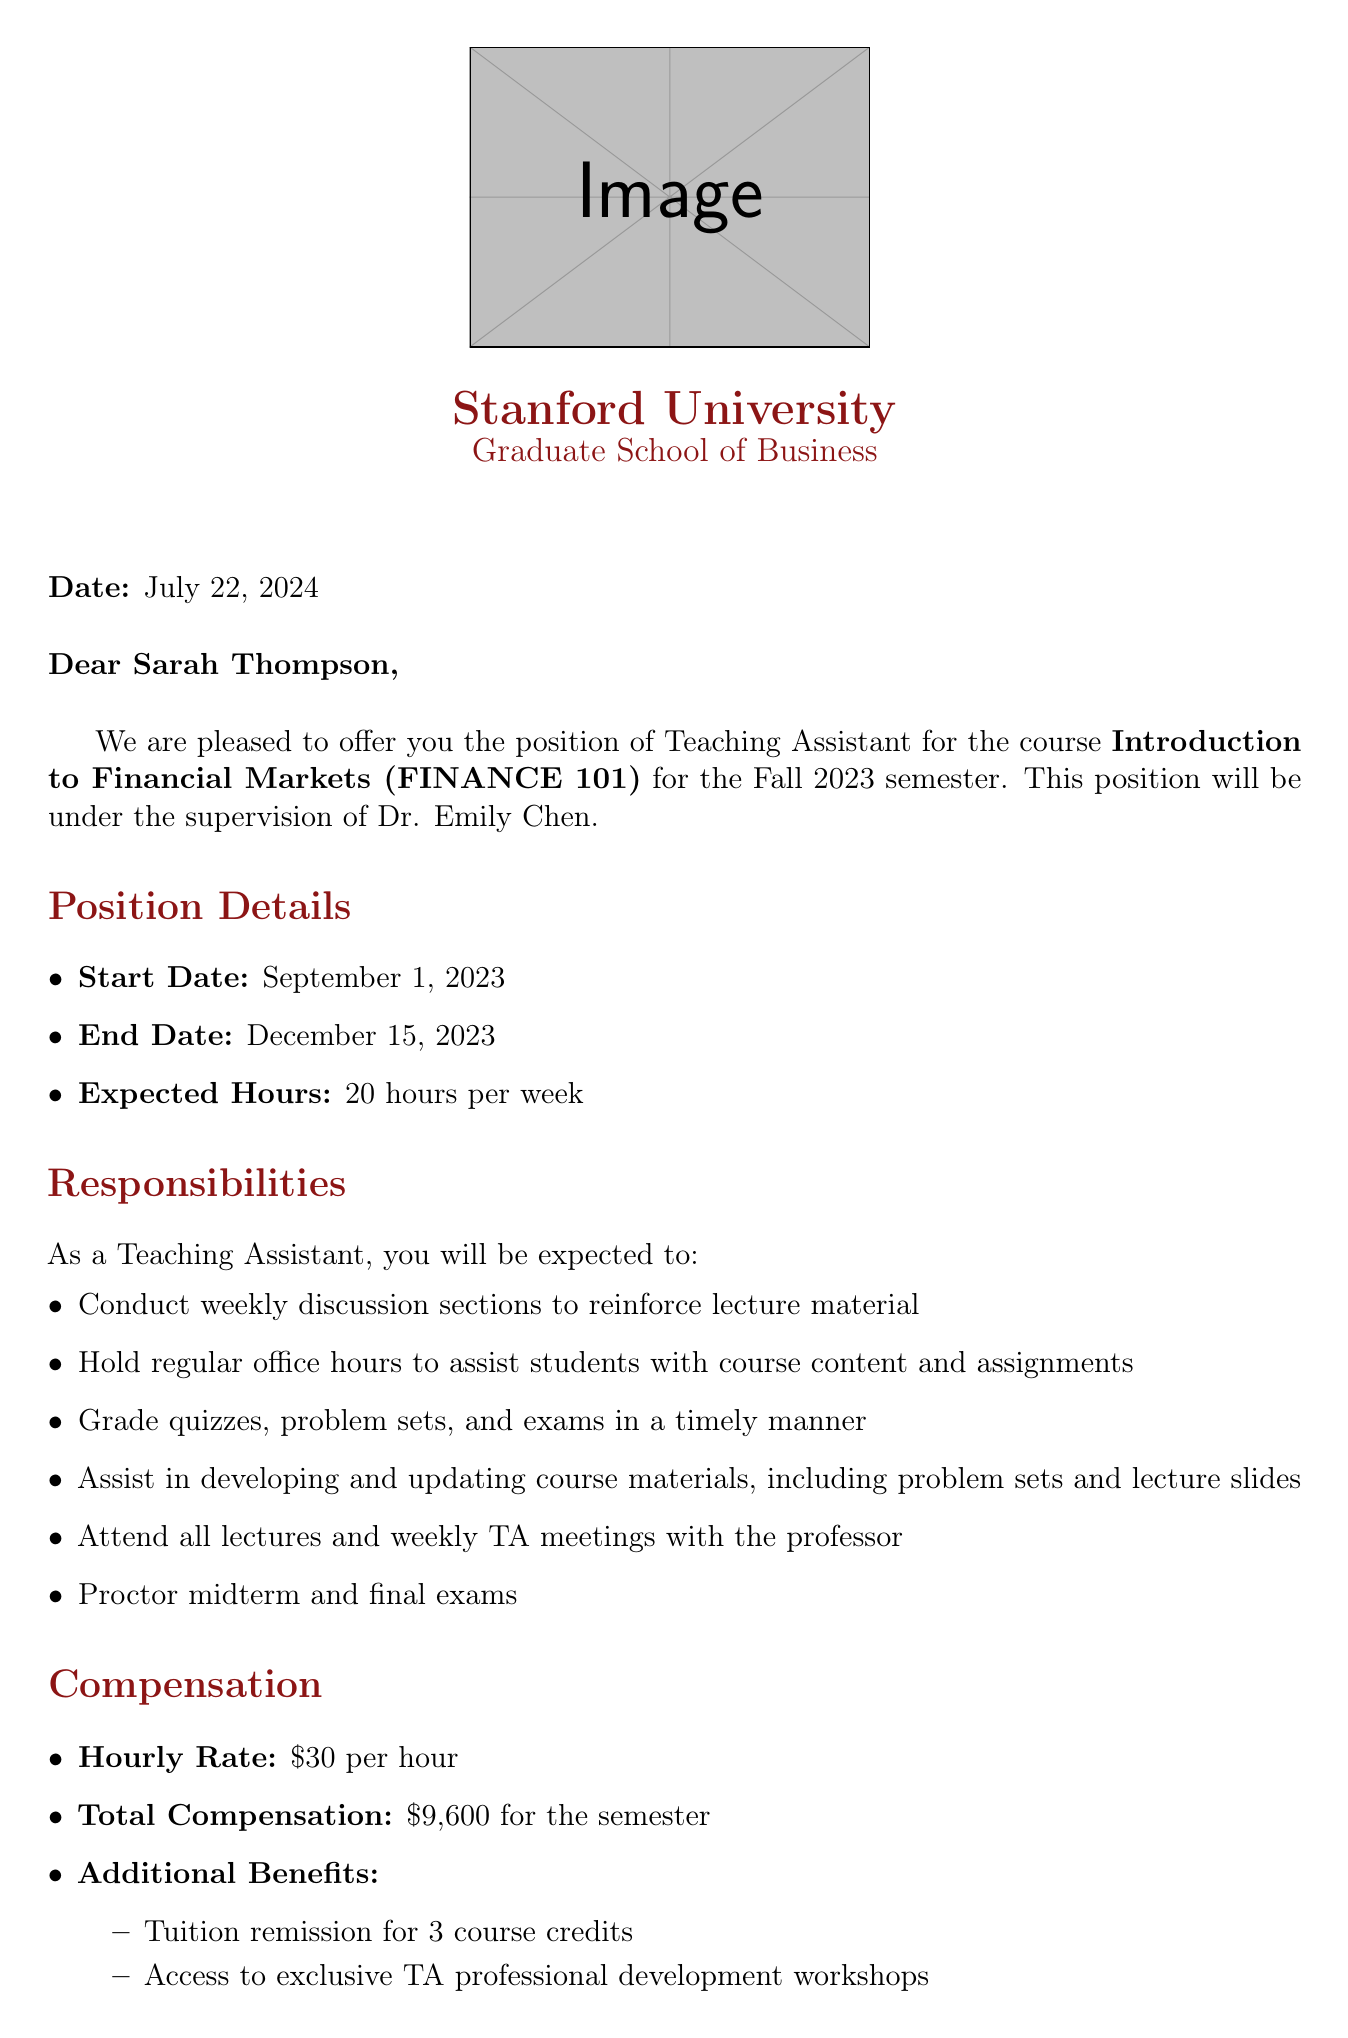What is the name of the course? The course name is specified in the document as Introduction to Financial Markets.
Answer: Introduction to Financial Markets Who is the supervising professor? The document states that Dr. Emily Chen is the supervising professor for the position.
Answer: Dr. Emily Chen What is the total compensation for the semester? The total compensation is clearly stated in the compensation section of the document.
Answer: $9,600 for the semester When is the acceptance deadline? The document provides the specific date by which the acceptance must be completed.
Answer: August 15, 2023 How many expected hours will the teaching assistant work per week? The expected hours per week are mentioned directly in the position details section.
Answer: 20 hours per week What type of additional benefits does the position offer? The document lists specific benefits, providing insight into the value of the position.
Answer: Tuition remission and access to workshops What will be one of the responsibilities of the Teaching Assistant? The responsibilities section outlines specific tasks the assistant will perform.
Answer: Conduct weekly discussion sections When does the position start? The start date is explicitly mentioned in the position details of the document.
Answer: September 1, 2023 Who should be contacted to accept the position? The document identifies the contact person responsible for acceptance.
Answer: Ms. Jennifer Lee 